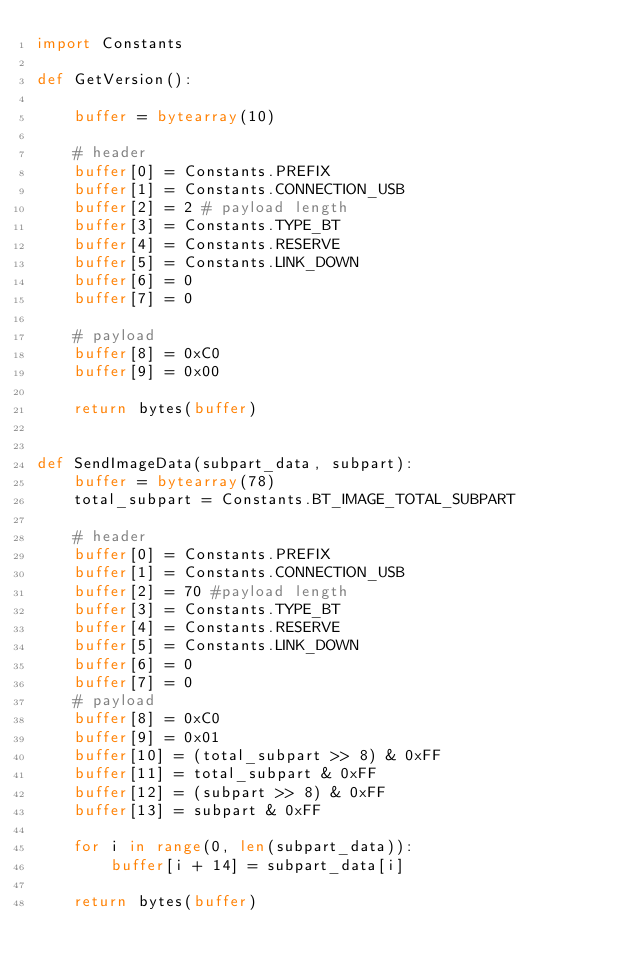Convert code to text. <code><loc_0><loc_0><loc_500><loc_500><_Python_>import Constants

def GetVersion():

    buffer = bytearray(10)

    # header
    buffer[0] = Constants.PREFIX
    buffer[1] = Constants.CONNECTION_USB
    buffer[2] = 2 # payload length
    buffer[3] = Constants.TYPE_BT
    buffer[4] = Constants.RESERVE
    buffer[5] = Constants.LINK_DOWN
    buffer[6] = 0
    buffer[7] = 0

    # payload
    buffer[8] = 0xC0
    buffer[9] = 0x00

    return bytes(buffer)


def SendImageData(subpart_data, subpart):
    buffer = bytearray(78)
    total_subpart = Constants.BT_IMAGE_TOTAL_SUBPART

    # header
    buffer[0] = Constants.PREFIX
    buffer[1] = Constants.CONNECTION_USB
    buffer[2] = 70 #payload length
    buffer[3] = Constants.TYPE_BT
    buffer[4] = Constants.RESERVE
    buffer[5] = Constants.LINK_DOWN
    buffer[6] = 0
    buffer[7] = 0
    # payload
    buffer[8] = 0xC0
    buffer[9] = 0x01
    buffer[10] = (total_subpart >> 8) & 0xFF
    buffer[11] = total_subpart & 0xFF
    buffer[12] = (subpart >> 8) & 0xFF
    buffer[13] = subpart & 0xFF

    for i in range(0, len(subpart_data)):
        buffer[i + 14] = subpart_data[i]

    return bytes(buffer)
</code> 